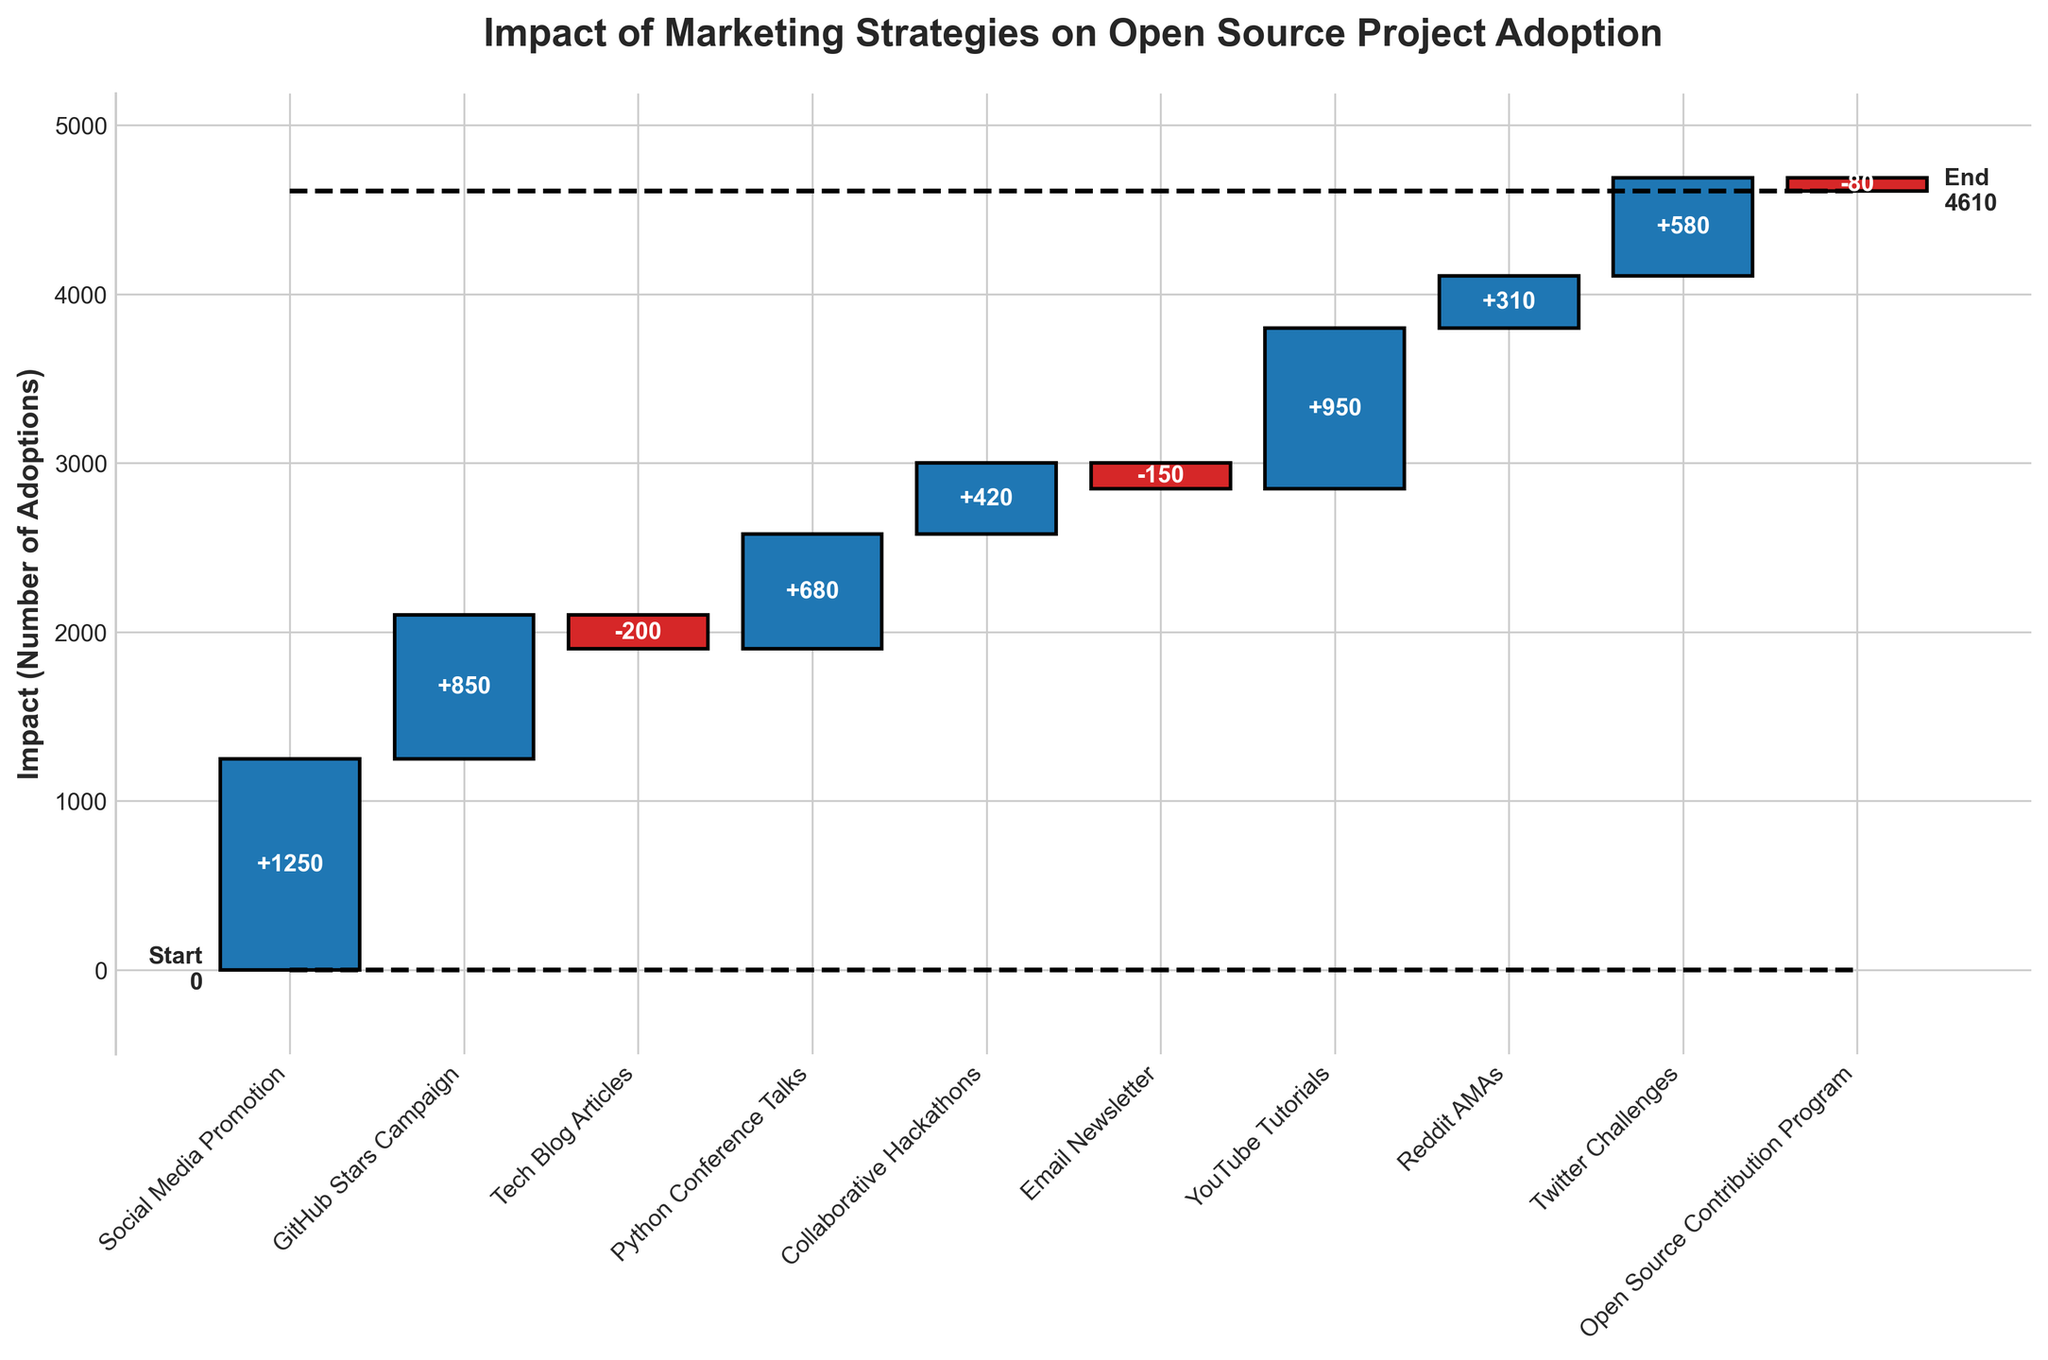How many marketing strategies are shown in the chart? Count the number of bars, each representing a marketing strategy. There are 10 strategies listed on the x-axis.
Answer: 10 Which marketing strategy has the highest positive impact? Identify the tallest bar with a positive increment from the base (previous total). The "Social Media Promotion" strategy has the tallest bar with a positive impact.
Answer: Social Media Promotion What is the cumulative impact after all the marketing strategies are applied? Look at the final value indicated at the end of the last bar. The cumulative impact is 5,610.
Answer: 5,610 Which marketing strategy has a negative impact and reduces the adoption rate the most? Identify the bar with the largest negative impact below the baseline. The "Tech Blog Articles" strategy has the largest negative impact of -200.
Answer: Tech Blog Articles What is the starting point of the cumulative impact before any marketing strategies are applied? Look at the starting point marked by the dashed line at the beginning of the chart, which is 0.
Answer: 0 How much does the "GitHub Stars Campaign" contribute to the adoption rate? Refer to the height of the bar labeled "GitHub Stars Campaign" and read off the impact, which is 850.
Answer: 850 How does the contribution of "YouTube Tutorials" compare to "Twitter Challenges"? Compare the heights of the bars for "YouTube Tutorials" and "Twitter Challenges". "YouTube Tutorials" has an impact of 950, while "Twitter Challenges" has an impact of 580. YouTube Tutorials contributes more.
Answer: YouTube Tutorials contributes more What is the net impact after "Tech Blog Articles" and "Email Newsletter"? Sum the negative impacts of these two strategies: -200 (Tech Blog Articles) + (-150) (Email Newsletter) = -350.
Answer: -350 Which strategies result in a positive cumulative gain? Identify strategies with bars above the baseline. These include: Social Media Promotion, GitHub Stars Campaign, Python Conference Talks, Collaborative Hackathons, YouTube Tutorials, Reddit AMAs, and Twitter Challenges.
Answer: Social Media Promotion, GitHub Stars Campaign, Python Conference Talks, Collaborative Hackathons, YouTube Tutorials, Reddit AMAs, Twitter Challenges What is the total increase in adoption rates contributed by all positive impact strategies? Add the values of all positive impact strategies: 1250 + 850 + 680 + 420 + 950 + 310 + 580 = 5,040.
Answer: 5,040 